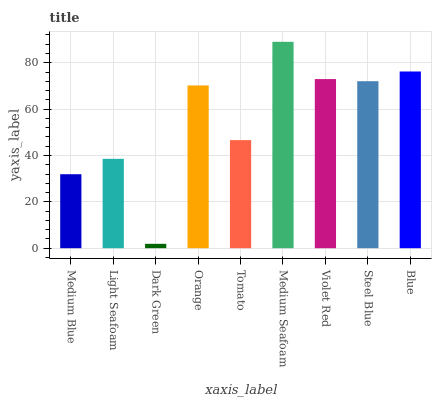Is Dark Green the minimum?
Answer yes or no. Yes. Is Medium Seafoam the maximum?
Answer yes or no. Yes. Is Light Seafoam the minimum?
Answer yes or no. No. Is Light Seafoam the maximum?
Answer yes or no. No. Is Light Seafoam greater than Medium Blue?
Answer yes or no. Yes. Is Medium Blue less than Light Seafoam?
Answer yes or no. Yes. Is Medium Blue greater than Light Seafoam?
Answer yes or no. No. Is Light Seafoam less than Medium Blue?
Answer yes or no. No. Is Orange the high median?
Answer yes or no. Yes. Is Orange the low median?
Answer yes or no. Yes. Is Light Seafoam the high median?
Answer yes or no. No. Is Light Seafoam the low median?
Answer yes or no. No. 